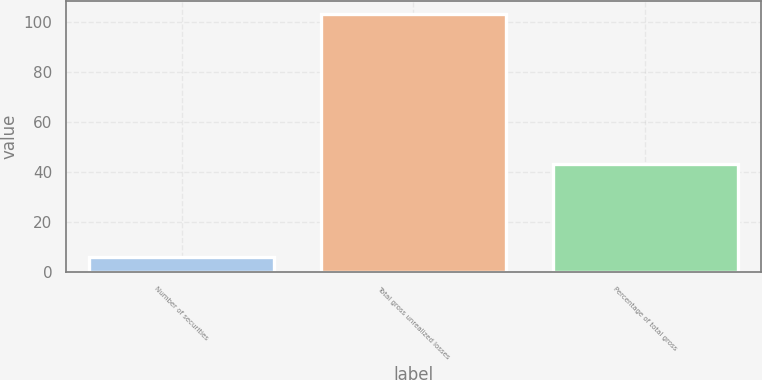<chart> <loc_0><loc_0><loc_500><loc_500><bar_chart><fcel>Number of securities<fcel>Total gross unrealized losses<fcel>Percentage of total gross<nl><fcel>6<fcel>103<fcel>43<nl></chart> 